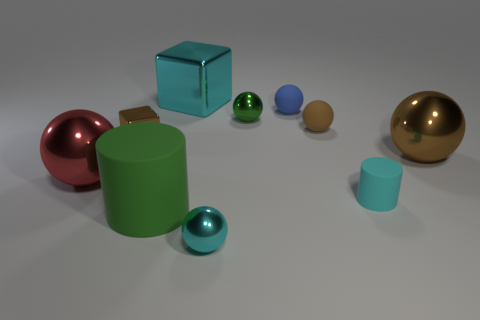Subtract all green spheres. How many spheres are left? 5 Subtract 3 spheres. How many spheres are left? 3 Subtract all cyan balls. How many balls are left? 5 Subtract all blue spheres. Subtract all red cubes. How many spheres are left? 5 Subtract all cylinders. How many objects are left? 8 Add 8 purple metallic cylinders. How many purple metallic cylinders exist? 8 Subtract 0 yellow cylinders. How many objects are left? 10 Subtract all small blue rubber balls. Subtract all green metal objects. How many objects are left? 8 Add 1 cyan matte cylinders. How many cyan matte cylinders are left? 2 